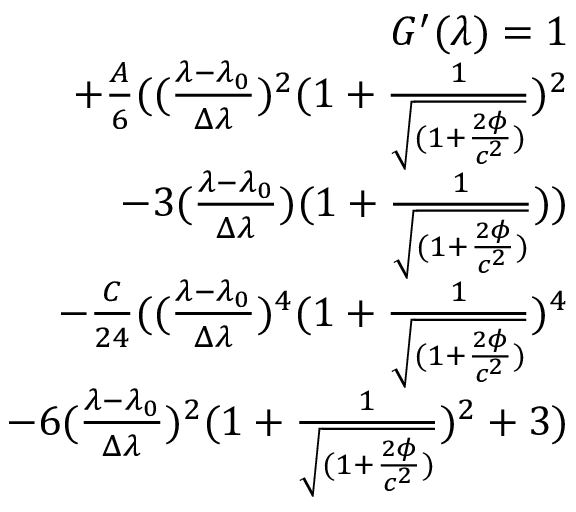Convert formula to latex. <formula><loc_0><loc_0><loc_500><loc_500>\begin{array} { r } { G ^ { \prime } ( \lambda ) = 1 } \\ { + \frac { A } { 6 } ( ( \frac { \lambda - \lambda _ { 0 } } { \Delta \lambda } ) ^ { 2 } ( 1 + \frac { 1 } { \sqrt { ( 1 + \frac { 2 \phi } { c ^ { 2 } } ) } } ) ^ { 2 } } \\ { - 3 ( \frac { \lambda - \lambda _ { 0 } } { \Delta \lambda } ) ( 1 + \frac { 1 } { \sqrt { ( 1 + \frac { 2 \phi } { c ^ { 2 } } ) } } ) ) } \\ { - \frac { C } { 2 4 } ( ( \frac { \lambda - \lambda _ { 0 } } { \Delta \lambda } ) ^ { 4 } ( 1 + \frac { 1 } { \sqrt { ( 1 + \frac { 2 \phi } { c ^ { 2 } } ) } } ) ^ { 4 } } \\ { - 6 ( \frac { \lambda - \lambda _ { 0 } } { \Delta \lambda } ) ^ { 2 } ( 1 + \frac { 1 } { \sqrt { ( 1 + \frac { 2 \phi } { c ^ { 2 } } ) } } ) ^ { 2 } + 3 ) } \end{array}</formula> 